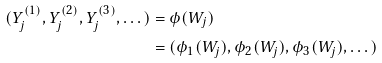<formula> <loc_0><loc_0><loc_500><loc_500>( Y _ { j } ^ { ( 1 ) } , Y _ { j } ^ { ( 2 ) } , Y _ { j } ^ { ( 3 ) } , \dots ) & = \phi ( W _ { j } ) \\ & = ( \phi _ { 1 } ( W _ { j } ) , \phi _ { 2 } ( W _ { j } ) , \phi _ { 3 } ( W _ { j } ) , \dots )</formula> 